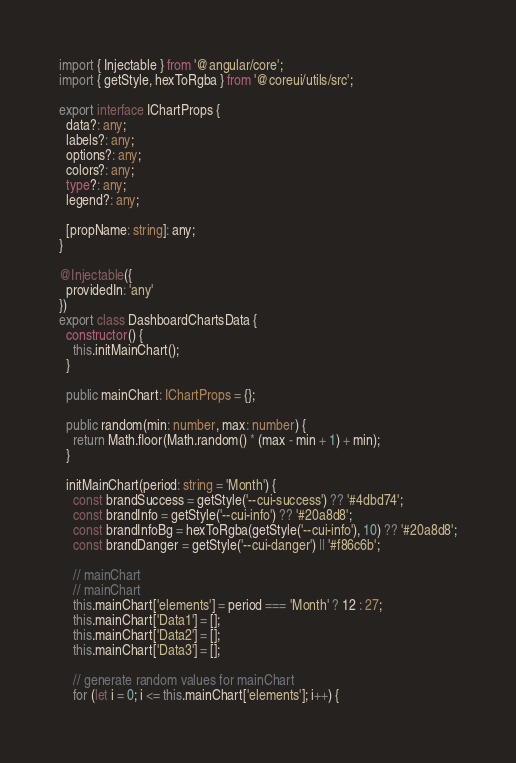Convert code to text. <code><loc_0><loc_0><loc_500><loc_500><_TypeScript_>import { Injectable } from '@angular/core';
import { getStyle, hexToRgba } from '@coreui/utils/src';

export interface IChartProps {
  data?: any;
  labels?: any;
  options?: any;
  colors?: any;
  type?: any;
  legend?: any;

  [propName: string]: any;
}

@Injectable({
  providedIn: 'any'
})
export class DashboardChartsData {
  constructor() {
    this.initMainChart();
  }

  public mainChart: IChartProps = {};

  public random(min: number, max: number) {
    return Math.floor(Math.random() * (max - min + 1) + min);
  }

  initMainChart(period: string = 'Month') {
    const brandSuccess = getStyle('--cui-success') ?? '#4dbd74';
    const brandInfo = getStyle('--cui-info') ?? '#20a8d8';
    const brandInfoBg = hexToRgba(getStyle('--cui-info'), 10) ?? '#20a8d8';
    const brandDanger = getStyle('--cui-danger') || '#f86c6b';

    // mainChart
    // mainChart
    this.mainChart['elements'] = period === 'Month' ? 12 : 27;
    this.mainChart['Data1'] = [];
    this.mainChart['Data2'] = [];
    this.mainChart['Data3'] = [];

    // generate random values for mainChart
    for (let i = 0; i <= this.mainChart['elements']; i++) {</code> 